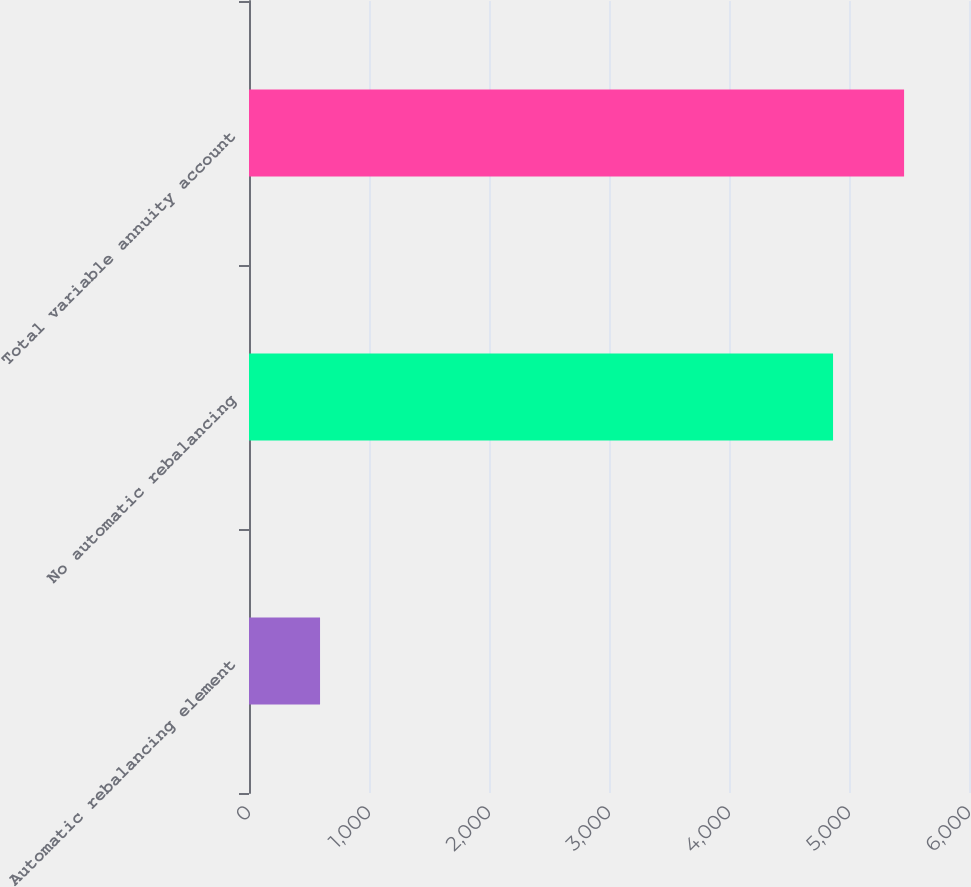Convert chart to OTSL. <chart><loc_0><loc_0><loc_500><loc_500><bar_chart><fcel>Automatic rebalancing element<fcel>No automatic rebalancing<fcel>Total variable annuity account<nl><fcel>592<fcel>4867<fcel>5459<nl></chart> 